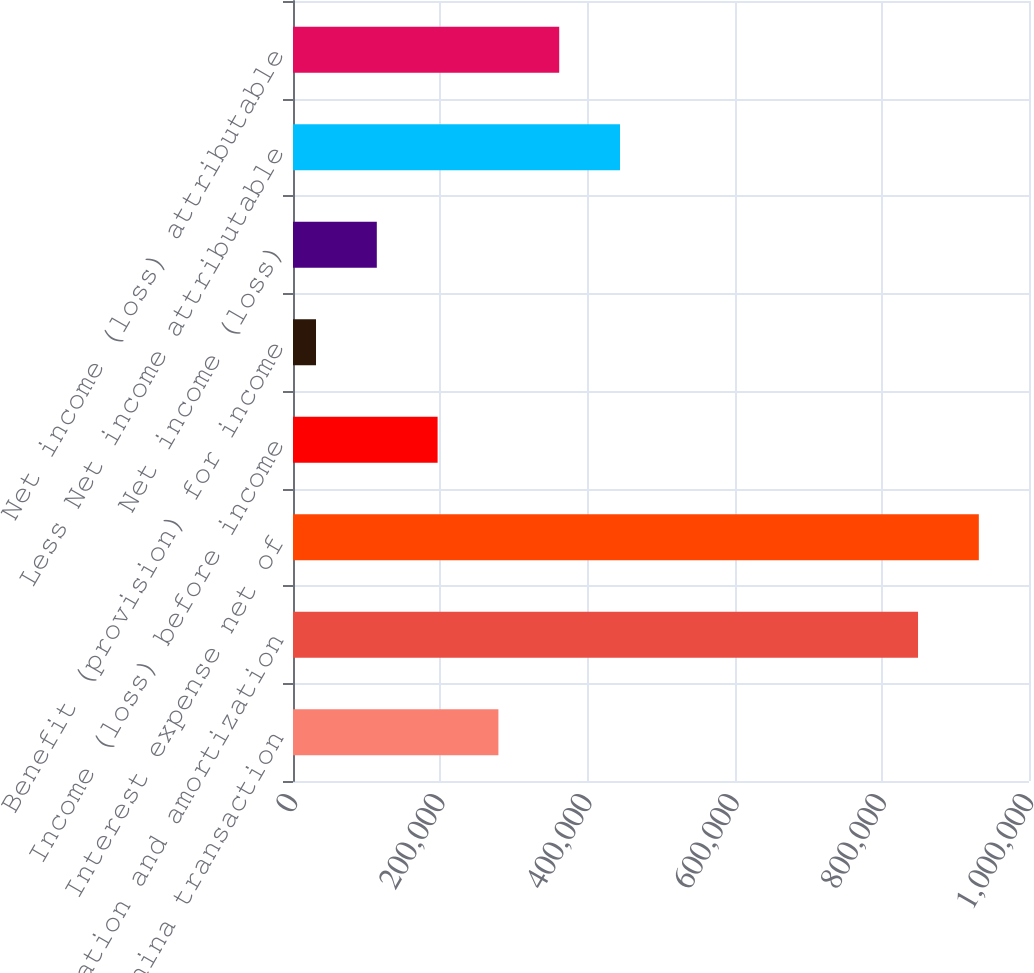Convert chart to OTSL. <chart><loc_0><loc_0><loc_500><loc_500><bar_chart><fcel>Gain on MGM China transaction<fcel>Depreciation and amortization<fcel>Interest expense net of<fcel>Income (loss) before income<fcel>Benefit (provision) for income<fcel>Net income (loss)<fcel>Less Net income attributable<fcel>Net income (loss) attributable<nl><fcel>279088<fcel>849225<fcel>931833<fcel>196480<fcel>31263<fcel>113871<fcel>444305<fcel>361697<nl></chart> 